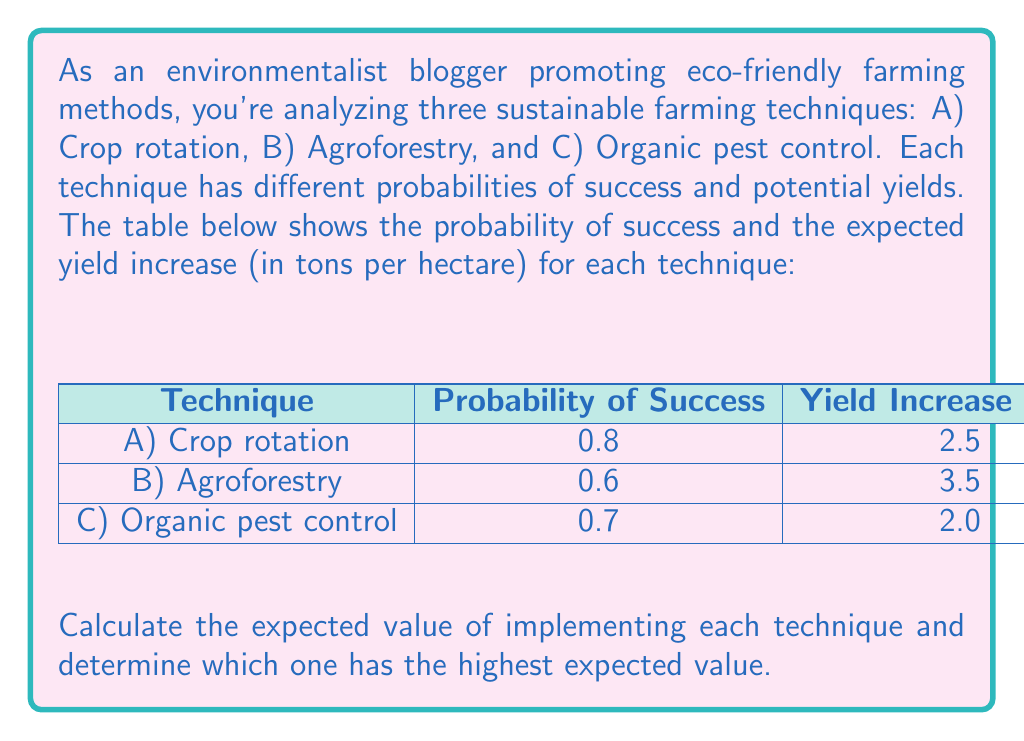Can you solve this math problem? To solve this problem, we need to calculate the expected value for each technique using the formula:

$$ E(X) = p(X) \cdot v(X) $$

Where $E(X)$ is the expected value, $p(X)$ is the probability of success, and $v(X)$ is the value (yield increase) if successful.

Let's calculate the expected value for each technique:

1. Technique A (Crop rotation):
   $E(A) = 0.8 \cdot 2.5 = 2.0$ tons per hectare

2. Technique B (Agroforestry):
   $E(B) = 0.6 \cdot 3.5 = 2.1$ tons per hectare

3. Technique C (Organic pest control):
   $E(C) = 0.7 \cdot 2.0 = 1.4$ tons per hectare

Now, we compare the expected values:

$E(A) = 2.0$ t/ha
$E(B) = 2.1$ t/ha
$E(C) = 1.4$ t/ha

The technique with the highest expected value is Technique B (Agroforestry) with 2.1 tons per hectare.
Answer: Technique B (Agroforestry) has the highest expected value of 2.1 tons per hectare. 